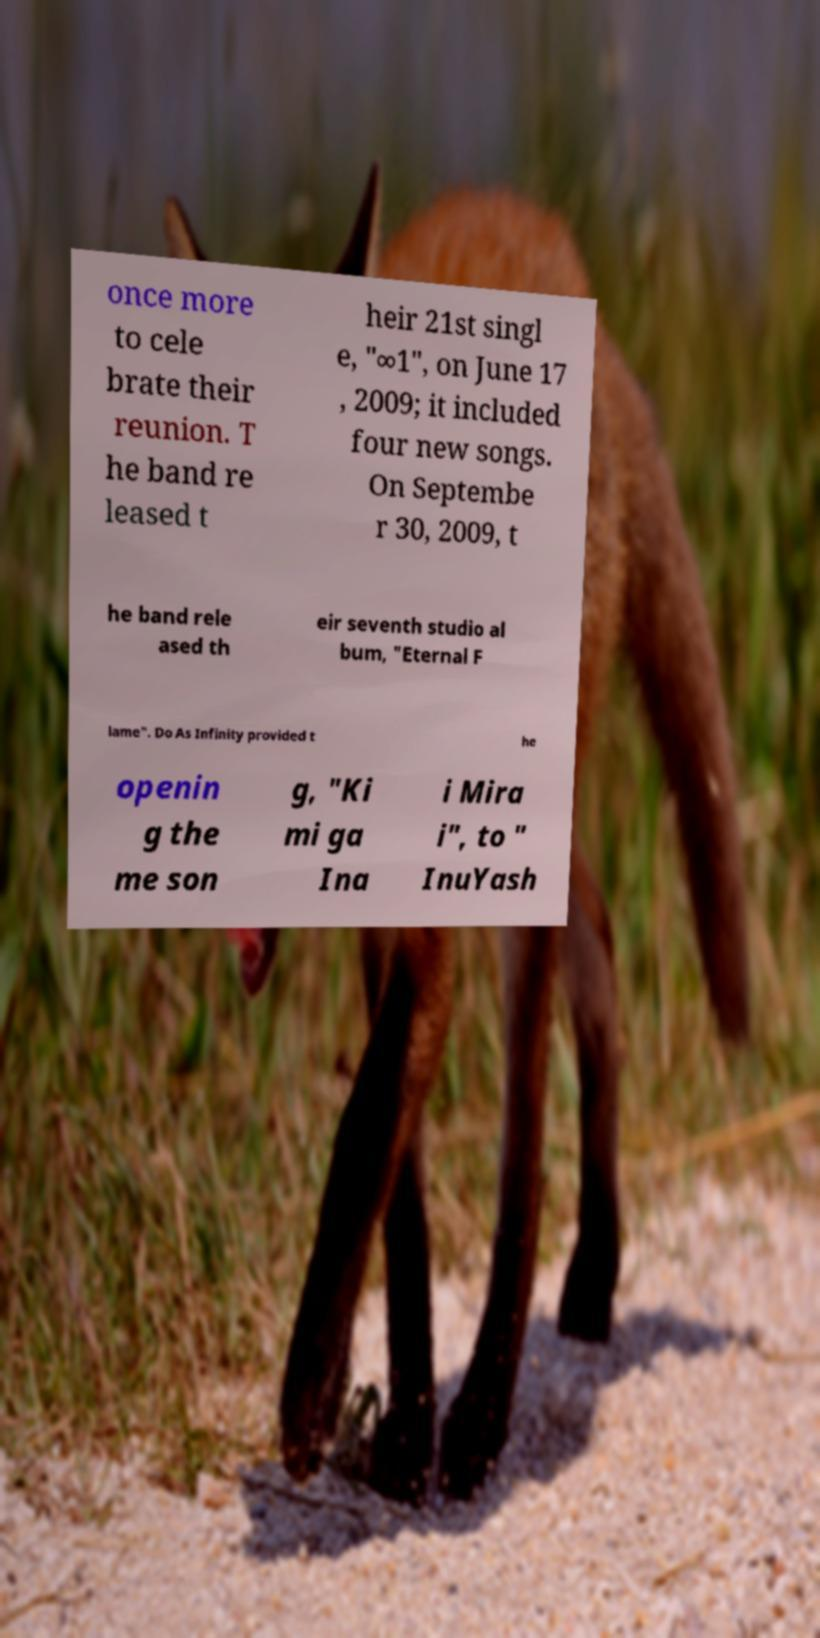I need the written content from this picture converted into text. Can you do that? once more to cele brate their reunion. T he band re leased t heir 21st singl e, "∞1", on June 17 , 2009; it included four new songs. On Septembe r 30, 2009, t he band rele ased th eir seventh studio al bum, "Eternal F lame". Do As Infinity provided t he openin g the me son g, "Ki mi ga Ina i Mira i", to " InuYash 